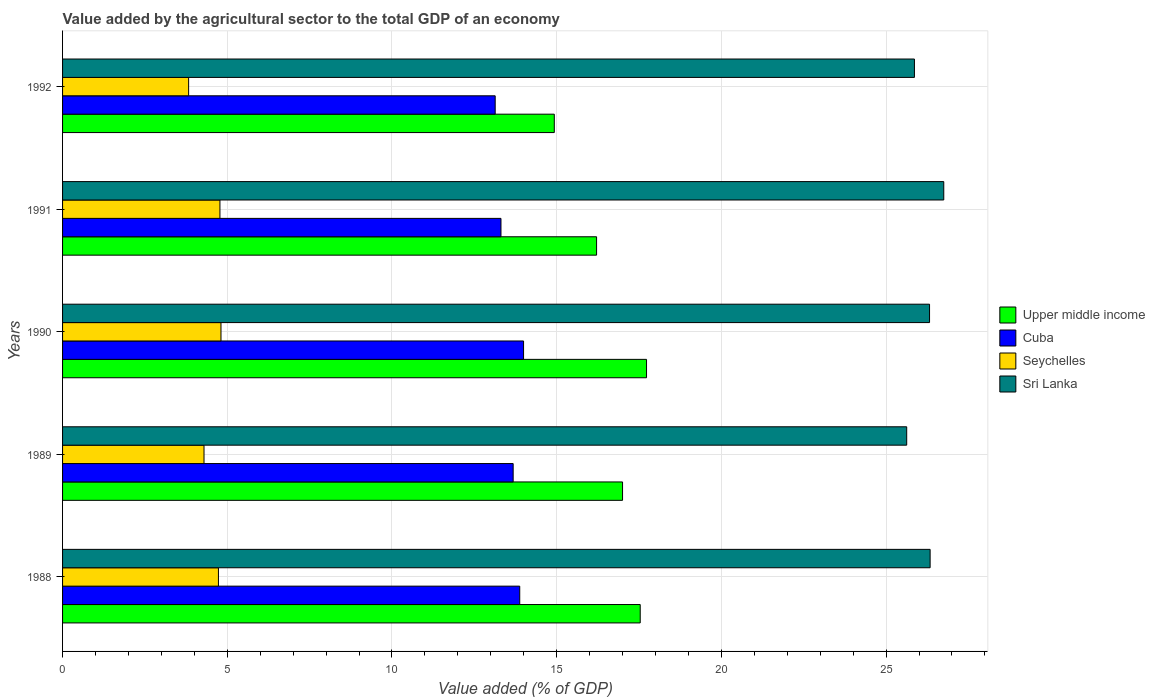How many different coloured bars are there?
Your answer should be compact. 4. Are the number of bars per tick equal to the number of legend labels?
Ensure brevity in your answer.  Yes. Are the number of bars on each tick of the Y-axis equal?
Provide a succinct answer. Yes. How many bars are there on the 3rd tick from the top?
Ensure brevity in your answer.  4. In how many cases, is the number of bars for a given year not equal to the number of legend labels?
Your response must be concise. 0. What is the value added by the agricultural sector to the total GDP in Cuba in 1992?
Provide a short and direct response. 13.13. Across all years, what is the maximum value added by the agricultural sector to the total GDP in Sri Lanka?
Offer a very short reply. 26.75. Across all years, what is the minimum value added by the agricultural sector to the total GDP in Upper middle income?
Make the answer very short. 14.93. What is the total value added by the agricultural sector to the total GDP in Seychelles in the graph?
Provide a short and direct response. 22.44. What is the difference between the value added by the agricultural sector to the total GDP in Cuba in 1991 and that in 1992?
Offer a very short reply. 0.18. What is the difference between the value added by the agricultural sector to the total GDP in Upper middle income in 1990 and the value added by the agricultural sector to the total GDP in Seychelles in 1991?
Offer a very short reply. 12.95. What is the average value added by the agricultural sector to the total GDP in Upper middle income per year?
Offer a very short reply. 16.68. In the year 1991, what is the difference between the value added by the agricultural sector to the total GDP in Cuba and value added by the agricultural sector to the total GDP in Sri Lanka?
Your answer should be very brief. -13.44. What is the ratio of the value added by the agricultural sector to the total GDP in Cuba in 1988 to that in 1992?
Offer a terse response. 1.06. Is the value added by the agricultural sector to the total GDP in Upper middle income in 1991 less than that in 1992?
Offer a terse response. No. What is the difference between the highest and the second highest value added by the agricultural sector to the total GDP in Cuba?
Your answer should be very brief. 0.12. What is the difference between the highest and the lowest value added by the agricultural sector to the total GDP in Upper middle income?
Make the answer very short. 2.8. In how many years, is the value added by the agricultural sector to the total GDP in Upper middle income greater than the average value added by the agricultural sector to the total GDP in Upper middle income taken over all years?
Offer a very short reply. 3. Is the sum of the value added by the agricultural sector to the total GDP in Upper middle income in 1988 and 1991 greater than the maximum value added by the agricultural sector to the total GDP in Seychelles across all years?
Provide a succinct answer. Yes. Is it the case that in every year, the sum of the value added by the agricultural sector to the total GDP in Cuba and value added by the agricultural sector to the total GDP in Seychelles is greater than the sum of value added by the agricultural sector to the total GDP in Upper middle income and value added by the agricultural sector to the total GDP in Sri Lanka?
Your answer should be very brief. No. What does the 1st bar from the top in 1991 represents?
Ensure brevity in your answer.  Sri Lanka. What does the 3rd bar from the bottom in 1988 represents?
Offer a terse response. Seychelles. Is it the case that in every year, the sum of the value added by the agricultural sector to the total GDP in Cuba and value added by the agricultural sector to the total GDP in Sri Lanka is greater than the value added by the agricultural sector to the total GDP in Upper middle income?
Ensure brevity in your answer.  Yes. How many bars are there?
Your answer should be very brief. 20. Are all the bars in the graph horizontal?
Provide a short and direct response. Yes. What is the difference between two consecutive major ticks on the X-axis?
Give a very brief answer. 5. Where does the legend appear in the graph?
Give a very brief answer. Center right. How many legend labels are there?
Provide a short and direct response. 4. What is the title of the graph?
Give a very brief answer. Value added by the agricultural sector to the total GDP of an economy. Does "European Union" appear as one of the legend labels in the graph?
Offer a terse response. No. What is the label or title of the X-axis?
Your response must be concise. Value added (% of GDP). What is the Value added (% of GDP) in Upper middle income in 1988?
Ensure brevity in your answer.  17.54. What is the Value added (% of GDP) of Cuba in 1988?
Offer a terse response. 13.88. What is the Value added (% of GDP) in Seychelles in 1988?
Ensure brevity in your answer.  4.73. What is the Value added (% of GDP) in Sri Lanka in 1988?
Provide a succinct answer. 26.34. What is the Value added (% of GDP) in Upper middle income in 1989?
Ensure brevity in your answer.  17. What is the Value added (% of GDP) in Cuba in 1989?
Provide a succinct answer. 13.68. What is the Value added (% of GDP) of Seychelles in 1989?
Your answer should be compact. 4.29. What is the Value added (% of GDP) in Sri Lanka in 1989?
Offer a very short reply. 25.63. What is the Value added (% of GDP) in Upper middle income in 1990?
Provide a short and direct response. 17.73. What is the Value added (% of GDP) in Cuba in 1990?
Provide a succinct answer. 13.99. What is the Value added (% of GDP) of Seychelles in 1990?
Make the answer very short. 4.81. What is the Value added (% of GDP) in Sri Lanka in 1990?
Your response must be concise. 26.32. What is the Value added (% of GDP) of Upper middle income in 1991?
Your response must be concise. 16.21. What is the Value added (% of GDP) of Cuba in 1991?
Provide a short and direct response. 13.31. What is the Value added (% of GDP) of Seychelles in 1991?
Offer a very short reply. 4.78. What is the Value added (% of GDP) in Sri Lanka in 1991?
Provide a succinct answer. 26.75. What is the Value added (% of GDP) in Upper middle income in 1992?
Offer a very short reply. 14.93. What is the Value added (% of GDP) of Cuba in 1992?
Offer a terse response. 13.13. What is the Value added (% of GDP) of Seychelles in 1992?
Keep it short and to the point. 3.83. What is the Value added (% of GDP) of Sri Lanka in 1992?
Give a very brief answer. 25.86. Across all years, what is the maximum Value added (% of GDP) in Upper middle income?
Make the answer very short. 17.73. Across all years, what is the maximum Value added (% of GDP) of Cuba?
Your answer should be very brief. 13.99. Across all years, what is the maximum Value added (% of GDP) of Seychelles?
Keep it short and to the point. 4.81. Across all years, what is the maximum Value added (% of GDP) of Sri Lanka?
Ensure brevity in your answer.  26.75. Across all years, what is the minimum Value added (% of GDP) of Upper middle income?
Your answer should be very brief. 14.93. Across all years, what is the minimum Value added (% of GDP) of Cuba?
Offer a terse response. 13.13. Across all years, what is the minimum Value added (% of GDP) of Seychelles?
Provide a short and direct response. 3.83. Across all years, what is the minimum Value added (% of GDP) of Sri Lanka?
Give a very brief answer. 25.63. What is the total Value added (% of GDP) of Upper middle income in the graph?
Your answer should be compact. 83.4. What is the total Value added (% of GDP) of Cuba in the graph?
Provide a short and direct response. 67.99. What is the total Value added (% of GDP) in Seychelles in the graph?
Keep it short and to the point. 22.44. What is the total Value added (% of GDP) in Sri Lanka in the graph?
Your answer should be compact. 130.89. What is the difference between the Value added (% of GDP) of Upper middle income in 1988 and that in 1989?
Keep it short and to the point. 0.54. What is the difference between the Value added (% of GDP) in Cuba in 1988 and that in 1989?
Your response must be concise. 0.2. What is the difference between the Value added (% of GDP) of Seychelles in 1988 and that in 1989?
Your answer should be compact. 0.44. What is the difference between the Value added (% of GDP) in Sri Lanka in 1988 and that in 1989?
Keep it short and to the point. 0.71. What is the difference between the Value added (% of GDP) of Upper middle income in 1988 and that in 1990?
Ensure brevity in your answer.  -0.19. What is the difference between the Value added (% of GDP) of Cuba in 1988 and that in 1990?
Ensure brevity in your answer.  -0.12. What is the difference between the Value added (% of GDP) of Seychelles in 1988 and that in 1990?
Your answer should be compact. -0.08. What is the difference between the Value added (% of GDP) of Sri Lanka in 1988 and that in 1990?
Provide a succinct answer. 0.02. What is the difference between the Value added (% of GDP) in Upper middle income in 1988 and that in 1991?
Keep it short and to the point. 1.32. What is the difference between the Value added (% of GDP) in Cuba in 1988 and that in 1991?
Offer a terse response. 0.57. What is the difference between the Value added (% of GDP) in Seychelles in 1988 and that in 1991?
Make the answer very short. -0.05. What is the difference between the Value added (% of GDP) of Sri Lanka in 1988 and that in 1991?
Ensure brevity in your answer.  -0.41. What is the difference between the Value added (% of GDP) of Upper middle income in 1988 and that in 1992?
Offer a very short reply. 2.61. What is the difference between the Value added (% of GDP) of Cuba in 1988 and that in 1992?
Ensure brevity in your answer.  0.75. What is the difference between the Value added (% of GDP) of Seychelles in 1988 and that in 1992?
Make the answer very short. 0.9. What is the difference between the Value added (% of GDP) of Sri Lanka in 1988 and that in 1992?
Give a very brief answer. 0.48. What is the difference between the Value added (% of GDP) of Upper middle income in 1989 and that in 1990?
Your answer should be very brief. -0.73. What is the difference between the Value added (% of GDP) of Cuba in 1989 and that in 1990?
Your response must be concise. -0.32. What is the difference between the Value added (% of GDP) in Seychelles in 1989 and that in 1990?
Ensure brevity in your answer.  -0.52. What is the difference between the Value added (% of GDP) of Sri Lanka in 1989 and that in 1990?
Offer a terse response. -0.69. What is the difference between the Value added (% of GDP) in Upper middle income in 1989 and that in 1991?
Offer a very short reply. 0.79. What is the difference between the Value added (% of GDP) of Cuba in 1989 and that in 1991?
Offer a very short reply. 0.37. What is the difference between the Value added (% of GDP) of Seychelles in 1989 and that in 1991?
Your answer should be compact. -0.48. What is the difference between the Value added (% of GDP) in Sri Lanka in 1989 and that in 1991?
Keep it short and to the point. -1.13. What is the difference between the Value added (% of GDP) in Upper middle income in 1989 and that in 1992?
Keep it short and to the point. 2.07. What is the difference between the Value added (% of GDP) of Cuba in 1989 and that in 1992?
Make the answer very short. 0.55. What is the difference between the Value added (% of GDP) in Seychelles in 1989 and that in 1992?
Give a very brief answer. 0.47. What is the difference between the Value added (% of GDP) in Sri Lanka in 1989 and that in 1992?
Keep it short and to the point. -0.23. What is the difference between the Value added (% of GDP) of Upper middle income in 1990 and that in 1991?
Provide a succinct answer. 1.52. What is the difference between the Value added (% of GDP) of Cuba in 1990 and that in 1991?
Make the answer very short. 0.69. What is the difference between the Value added (% of GDP) of Seychelles in 1990 and that in 1991?
Make the answer very short. 0.03. What is the difference between the Value added (% of GDP) in Sri Lanka in 1990 and that in 1991?
Offer a terse response. -0.43. What is the difference between the Value added (% of GDP) in Upper middle income in 1990 and that in 1992?
Provide a short and direct response. 2.8. What is the difference between the Value added (% of GDP) of Cuba in 1990 and that in 1992?
Provide a short and direct response. 0.86. What is the difference between the Value added (% of GDP) in Seychelles in 1990 and that in 1992?
Make the answer very short. 0.98. What is the difference between the Value added (% of GDP) of Sri Lanka in 1990 and that in 1992?
Ensure brevity in your answer.  0.46. What is the difference between the Value added (% of GDP) of Upper middle income in 1991 and that in 1992?
Make the answer very short. 1.28. What is the difference between the Value added (% of GDP) in Cuba in 1991 and that in 1992?
Keep it short and to the point. 0.18. What is the difference between the Value added (% of GDP) of Seychelles in 1991 and that in 1992?
Provide a short and direct response. 0.95. What is the difference between the Value added (% of GDP) of Sri Lanka in 1991 and that in 1992?
Offer a very short reply. 0.89. What is the difference between the Value added (% of GDP) of Upper middle income in 1988 and the Value added (% of GDP) of Cuba in 1989?
Provide a short and direct response. 3.86. What is the difference between the Value added (% of GDP) of Upper middle income in 1988 and the Value added (% of GDP) of Seychelles in 1989?
Ensure brevity in your answer.  13.24. What is the difference between the Value added (% of GDP) of Upper middle income in 1988 and the Value added (% of GDP) of Sri Lanka in 1989?
Your response must be concise. -8.09. What is the difference between the Value added (% of GDP) of Cuba in 1988 and the Value added (% of GDP) of Seychelles in 1989?
Keep it short and to the point. 9.58. What is the difference between the Value added (% of GDP) in Cuba in 1988 and the Value added (% of GDP) in Sri Lanka in 1989?
Provide a succinct answer. -11.75. What is the difference between the Value added (% of GDP) of Seychelles in 1988 and the Value added (% of GDP) of Sri Lanka in 1989?
Offer a very short reply. -20.89. What is the difference between the Value added (% of GDP) of Upper middle income in 1988 and the Value added (% of GDP) of Cuba in 1990?
Ensure brevity in your answer.  3.54. What is the difference between the Value added (% of GDP) in Upper middle income in 1988 and the Value added (% of GDP) in Seychelles in 1990?
Offer a very short reply. 12.73. What is the difference between the Value added (% of GDP) in Upper middle income in 1988 and the Value added (% of GDP) in Sri Lanka in 1990?
Offer a terse response. -8.78. What is the difference between the Value added (% of GDP) of Cuba in 1988 and the Value added (% of GDP) of Seychelles in 1990?
Your response must be concise. 9.07. What is the difference between the Value added (% of GDP) in Cuba in 1988 and the Value added (% of GDP) in Sri Lanka in 1990?
Give a very brief answer. -12.44. What is the difference between the Value added (% of GDP) in Seychelles in 1988 and the Value added (% of GDP) in Sri Lanka in 1990?
Provide a short and direct response. -21.59. What is the difference between the Value added (% of GDP) in Upper middle income in 1988 and the Value added (% of GDP) in Cuba in 1991?
Keep it short and to the point. 4.23. What is the difference between the Value added (% of GDP) of Upper middle income in 1988 and the Value added (% of GDP) of Seychelles in 1991?
Your response must be concise. 12.76. What is the difference between the Value added (% of GDP) of Upper middle income in 1988 and the Value added (% of GDP) of Sri Lanka in 1991?
Your answer should be compact. -9.21. What is the difference between the Value added (% of GDP) in Cuba in 1988 and the Value added (% of GDP) in Seychelles in 1991?
Offer a terse response. 9.1. What is the difference between the Value added (% of GDP) of Cuba in 1988 and the Value added (% of GDP) of Sri Lanka in 1991?
Give a very brief answer. -12.87. What is the difference between the Value added (% of GDP) in Seychelles in 1988 and the Value added (% of GDP) in Sri Lanka in 1991?
Your answer should be compact. -22.02. What is the difference between the Value added (% of GDP) in Upper middle income in 1988 and the Value added (% of GDP) in Cuba in 1992?
Give a very brief answer. 4.4. What is the difference between the Value added (% of GDP) in Upper middle income in 1988 and the Value added (% of GDP) in Seychelles in 1992?
Offer a very short reply. 13.71. What is the difference between the Value added (% of GDP) of Upper middle income in 1988 and the Value added (% of GDP) of Sri Lanka in 1992?
Provide a short and direct response. -8.32. What is the difference between the Value added (% of GDP) in Cuba in 1988 and the Value added (% of GDP) in Seychelles in 1992?
Your answer should be compact. 10.05. What is the difference between the Value added (% of GDP) in Cuba in 1988 and the Value added (% of GDP) in Sri Lanka in 1992?
Your response must be concise. -11.98. What is the difference between the Value added (% of GDP) in Seychelles in 1988 and the Value added (% of GDP) in Sri Lanka in 1992?
Provide a short and direct response. -21.13. What is the difference between the Value added (% of GDP) in Upper middle income in 1989 and the Value added (% of GDP) in Cuba in 1990?
Keep it short and to the point. 3. What is the difference between the Value added (% of GDP) in Upper middle income in 1989 and the Value added (% of GDP) in Seychelles in 1990?
Provide a succinct answer. 12.19. What is the difference between the Value added (% of GDP) of Upper middle income in 1989 and the Value added (% of GDP) of Sri Lanka in 1990?
Your answer should be compact. -9.32. What is the difference between the Value added (% of GDP) in Cuba in 1989 and the Value added (% of GDP) in Seychelles in 1990?
Ensure brevity in your answer.  8.87. What is the difference between the Value added (% of GDP) of Cuba in 1989 and the Value added (% of GDP) of Sri Lanka in 1990?
Your answer should be very brief. -12.64. What is the difference between the Value added (% of GDP) in Seychelles in 1989 and the Value added (% of GDP) in Sri Lanka in 1990?
Give a very brief answer. -22.03. What is the difference between the Value added (% of GDP) of Upper middle income in 1989 and the Value added (% of GDP) of Cuba in 1991?
Your response must be concise. 3.69. What is the difference between the Value added (% of GDP) in Upper middle income in 1989 and the Value added (% of GDP) in Seychelles in 1991?
Offer a terse response. 12.22. What is the difference between the Value added (% of GDP) of Upper middle income in 1989 and the Value added (% of GDP) of Sri Lanka in 1991?
Offer a terse response. -9.75. What is the difference between the Value added (% of GDP) of Cuba in 1989 and the Value added (% of GDP) of Seychelles in 1991?
Give a very brief answer. 8.9. What is the difference between the Value added (% of GDP) of Cuba in 1989 and the Value added (% of GDP) of Sri Lanka in 1991?
Keep it short and to the point. -13.07. What is the difference between the Value added (% of GDP) in Seychelles in 1989 and the Value added (% of GDP) in Sri Lanka in 1991?
Give a very brief answer. -22.46. What is the difference between the Value added (% of GDP) of Upper middle income in 1989 and the Value added (% of GDP) of Cuba in 1992?
Your answer should be very brief. 3.87. What is the difference between the Value added (% of GDP) of Upper middle income in 1989 and the Value added (% of GDP) of Seychelles in 1992?
Your answer should be very brief. 13.17. What is the difference between the Value added (% of GDP) in Upper middle income in 1989 and the Value added (% of GDP) in Sri Lanka in 1992?
Make the answer very short. -8.86. What is the difference between the Value added (% of GDP) in Cuba in 1989 and the Value added (% of GDP) in Seychelles in 1992?
Give a very brief answer. 9.85. What is the difference between the Value added (% of GDP) of Cuba in 1989 and the Value added (% of GDP) of Sri Lanka in 1992?
Give a very brief answer. -12.18. What is the difference between the Value added (% of GDP) of Seychelles in 1989 and the Value added (% of GDP) of Sri Lanka in 1992?
Provide a succinct answer. -21.57. What is the difference between the Value added (% of GDP) in Upper middle income in 1990 and the Value added (% of GDP) in Cuba in 1991?
Keep it short and to the point. 4.42. What is the difference between the Value added (% of GDP) of Upper middle income in 1990 and the Value added (% of GDP) of Seychelles in 1991?
Give a very brief answer. 12.95. What is the difference between the Value added (% of GDP) in Upper middle income in 1990 and the Value added (% of GDP) in Sri Lanka in 1991?
Your answer should be very brief. -9.02. What is the difference between the Value added (% of GDP) of Cuba in 1990 and the Value added (% of GDP) of Seychelles in 1991?
Provide a succinct answer. 9.22. What is the difference between the Value added (% of GDP) of Cuba in 1990 and the Value added (% of GDP) of Sri Lanka in 1991?
Your answer should be very brief. -12.76. What is the difference between the Value added (% of GDP) of Seychelles in 1990 and the Value added (% of GDP) of Sri Lanka in 1991?
Ensure brevity in your answer.  -21.94. What is the difference between the Value added (% of GDP) of Upper middle income in 1990 and the Value added (% of GDP) of Cuba in 1992?
Give a very brief answer. 4.59. What is the difference between the Value added (% of GDP) of Upper middle income in 1990 and the Value added (% of GDP) of Seychelles in 1992?
Your answer should be very brief. 13.9. What is the difference between the Value added (% of GDP) of Upper middle income in 1990 and the Value added (% of GDP) of Sri Lanka in 1992?
Ensure brevity in your answer.  -8.13. What is the difference between the Value added (% of GDP) in Cuba in 1990 and the Value added (% of GDP) in Seychelles in 1992?
Give a very brief answer. 10.17. What is the difference between the Value added (% of GDP) of Cuba in 1990 and the Value added (% of GDP) of Sri Lanka in 1992?
Offer a terse response. -11.87. What is the difference between the Value added (% of GDP) of Seychelles in 1990 and the Value added (% of GDP) of Sri Lanka in 1992?
Offer a terse response. -21.05. What is the difference between the Value added (% of GDP) in Upper middle income in 1991 and the Value added (% of GDP) in Cuba in 1992?
Offer a terse response. 3.08. What is the difference between the Value added (% of GDP) in Upper middle income in 1991 and the Value added (% of GDP) in Seychelles in 1992?
Keep it short and to the point. 12.38. What is the difference between the Value added (% of GDP) in Upper middle income in 1991 and the Value added (% of GDP) in Sri Lanka in 1992?
Provide a succinct answer. -9.65. What is the difference between the Value added (% of GDP) in Cuba in 1991 and the Value added (% of GDP) in Seychelles in 1992?
Ensure brevity in your answer.  9.48. What is the difference between the Value added (% of GDP) in Cuba in 1991 and the Value added (% of GDP) in Sri Lanka in 1992?
Provide a succinct answer. -12.55. What is the difference between the Value added (% of GDP) in Seychelles in 1991 and the Value added (% of GDP) in Sri Lanka in 1992?
Provide a short and direct response. -21.08. What is the average Value added (% of GDP) in Upper middle income per year?
Offer a terse response. 16.68. What is the average Value added (% of GDP) in Cuba per year?
Your answer should be compact. 13.6. What is the average Value added (% of GDP) in Seychelles per year?
Provide a short and direct response. 4.49. What is the average Value added (% of GDP) of Sri Lanka per year?
Provide a short and direct response. 26.18. In the year 1988, what is the difference between the Value added (% of GDP) in Upper middle income and Value added (% of GDP) in Cuba?
Your answer should be very brief. 3.66. In the year 1988, what is the difference between the Value added (% of GDP) of Upper middle income and Value added (% of GDP) of Seychelles?
Your answer should be very brief. 12.8. In the year 1988, what is the difference between the Value added (% of GDP) in Upper middle income and Value added (% of GDP) in Sri Lanka?
Your response must be concise. -8.8. In the year 1988, what is the difference between the Value added (% of GDP) of Cuba and Value added (% of GDP) of Seychelles?
Keep it short and to the point. 9.15. In the year 1988, what is the difference between the Value added (% of GDP) of Cuba and Value added (% of GDP) of Sri Lanka?
Give a very brief answer. -12.46. In the year 1988, what is the difference between the Value added (% of GDP) in Seychelles and Value added (% of GDP) in Sri Lanka?
Offer a very short reply. -21.61. In the year 1989, what is the difference between the Value added (% of GDP) in Upper middle income and Value added (% of GDP) in Cuba?
Your answer should be very brief. 3.32. In the year 1989, what is the difference between the Value added (% of GDP) in Upper middle income and Value added (% of GDP) in Seychelles?
Provide a short and direct response. 12.71. In the year 1989, what is the difference between the Value added (% of GDP) of Upper middle income and Value added (% of GDP) of Sri Lanka?
Provide a succinct answer. -8.63. In the year 1989, what is the difference between the Value added (% of GDP) in Cuba and Value added (% of GDP) in Seychelles?
Ensure brevity in your answer.  9.38. In the year 1989, what is the difference between the Value added (% of GDP) in Cuba and Value added (% of GDP) in Sri Lanka?
Ensure brevity in your answer.  -11.95. In the year 1989, what is the difference between the Value added (% of GDP) of Seychelles and Value added (% of GDP) of Sri Lanka?
Your answer should be compact. -21.33. In the year 1990, what is the difference between the Value added (% of GDP) in Upper middle income and Value added (% of GDP) in Cuba?
Provide a short and direct response. 3.73. In the year 1990, what is the difference between the Value added (% of GDP) in Upper middle income and Value added (% of GDP) in Seychelles?
Offer a very short reply. 12.92. In the year 1990, what is the difference between the Value added (% of GDP) of Upper middle income and Value added (% of GDP) of Sri Lanka?
Give a very brief answer. -8.59. In the year 1990, what is the difference between the Value added (% of GDP) of Cuba and Value added (% of GDP) of Seychelles?
Ensure brevity in your answer.  9.19. In the year 1990, what is the difference between the Value added (% of GDP) in Cuba and Value added (% of GDP) in Sri Lanka?
Provide a short and direct response. -12.32. In the year 1990, what is the difference between the Value added (% of GDP) in Seychelles and Value added (% of GDP) in Sri Lanka?
Offer a very short reply. -21.51. In the year 1991, what is the difference between the Value added (% of GDP) of Upper middle income and Value added (% of GDP) of Cuba?
Your response must be concise. 2.9. In the year 1991, what is the difference between the Value added (% of GDP) of Upper middle income and Value added (% of GDP) of Seychelles?
Provide a succinct answer. 11.43. In the year 1991, what is the difference between the Value added (% of GDP) in Upper middle income and Value added (% of GDP) in Sri Lanka?
Provide a succinct answer. -10.54. In the year 1991, what is the difference between the Value added (% of GDP) of Cuba and Value added (% of GDP) of Seychelles?
Keep it short and to the point. 8.53. In the year 1991, what is the difference between the Value added (% of GDP) in Cuba and Value added (% of GDP) in Sri Lanka?
Make the answer very short. -13.44. In the year 1991, what is the difference between the Value added (% of GDP) of Seychelles and Value added (% of GDP) of Sri Lanka?
Make the answer very short. -21.97. In the year 1992, what is the difference between the Value added (% of GDP) of Upper middle income and Value added (% of GDP) of Cuba?
Offer a terse response. 1.79. In the year 1992, what is the difference between the Value added (% of GDP) in Upper middle income and Value added (% of GDP) in Seychelles?
Offer a terse response. 11.1. In the year 1992, what is the difference between the Value added (% of GDP) of Upper middle income and Value added (% of GDP) of Sri Lanka?
Ensure brevity in your answer.  -10.93. In the year 1992, what is the difference between the Value added (% of GDP) of Cuba and Value added (% of GDP) of Seychelles?
Ensure brevity in your answer.  9.31. In the year 1992, what is the difference between the Value added (% of GDP) in Cuba and Value added (% of GDP) in Sri Lanka?
Your answer should be compact. -12.73. In the year 1992, what is the difference between the Value added (% of GDP) of Seychelles and Value added (% of GDP) of Sri Lanka?
Provide a succinct answer. -22.03. What is the ratio of the Value added (% of GDP) in Upper middle income in 1988 to that in 1989?
Ensure brevity in your answer.  1.03. What is the ratio of the Value added (% of GDP) of Cuba in 1988 to that in 1989?
Your answer should be very brief. 1.01. What is the ratio of the Value added (% of GDP) of Seychelles in 1988 to that in 1989?
Provide a short and direct response. 1.1. What is the ratio of the Value added (% of GDP) of Sri Lanka in 1988 to that in 1989?
Keep it short and to the point. 1.03. What is the ratio of the Value added (% of GDP) in Upper middle income in 1988 to that in 1990?
Offer a terse response. 0.99. What is the ratio of the Value added (% of GDP) of Seychelles in 1988 to that in 1990?
Your response must be concise. 0.98. What is the ratio of the Value added (% of GDP) of Upper middle income in 1988 to that in 1991?
Keep it short and to the point. 1.08. What is the ratio of the Value added (% of GDP) in Cuba in 1988 to that in 1991?
Offer a terse response. 1.04. What is the ratio of the Value added (% of GDP) of Seychelles in 1988 to that in 1991?
Give a very brief answer. 0.99. What is the ratio of the Value added (% of GDP) in Sri Lanka in 1988 to that in 1991?
Your answer should be compact. 0.98. What is the ratio of the Value added (% of GDP) of Upper middle income in 1988 to that in 1992?
Provide a short and direct response. 1.17. What is the ratio of the Value added (% of GDP) in Cuba in 1988 to that in 1992?
Your answer should be compact. 1.06. What is the ratio of the Value added (% of GDP) in Seychelles in 1988 to that in 1992?
Provide a succinct answer. 1.24. What is the ratio of the Value added (% of GDP) of Sri Lanka in 1988 to that in 1992?
Your response must be concise. 1.02. What is the ratio of the Value added (% of GDP) in Upper middle income in 1989 to that in 1990?
Give a very brief answer. 0.96. What is the ratio of the Value added (% of GDP) of Cuba in 1989 to that in 1990?
Your answer should be compact. 0.98. What is the ratio of the Value added (% of GDP) of Seychelles in 1989 to that in 1990?
Provide a short and direct response. 0.89. What is the ratio of the Value added (% of GDP) in Sri Lanka in 1989 to that in 1990?
Make the answer very short. 0.97. What is the ratio of the Value added (% of GDP) in Upper middle income in 1989 to that in 1991?
Ensure brevity in your answer.  1.05. What is the ratio of the Value added (% of GDP) of Cuba in 1989 to that in 1991?
Your response must be concise. 1.03. What is the ratio of the Value added (% of GDP) of Seychelles in 1989 to that in 1991?
Your answer should be very brief. 0.9. What is the ratio of the Value added (% of GDP) in Sri Lanka in 1989 to that in 1991?
Your answer should be compact. 0.96. What is the ratio of the Value added (% of GDP) in Upper middle income in 1989 to that in 1992?
Give a very brief answer. 1.14. What is the ratio of the Value added (% of GDP) of Cuba in 1989 to that in 1992?
Offer a terse response. 1.04. What is the ratio of the Value added (% of GDP) of Seychelles in 1989 to that in 1992?
Ensure brevity in your answer.  1.12. What is the ratio of the Value added (% of GDP) in Sri Lanka in 1989 to that in 1992?
Your answer should be compact. 0.99. What is the ratio of the Value added (% of GDP) in Upper middle income in 1990 to that in 1991?
Keep it short and to the point. 1.09. What is the ratio of the Value added (% of GDP) of Cuba in 1990 to that in 1991?
Provide a short and direct response. 1.05. What is the ratio of the Value added (% of GDP) in Seychelles in 1990 to that in 1991?
Your response must be concise. 1.01. What is the ratio of the Value added (% of GDP) in Sri Lanka in 1990 to that in 1991?
Your answer should be compact. 0.98. What is the ratio of the Value added (% of GDP) in Upper middle income in 1990 to that in 1992?
Make the answer very short. 1.19. What is the ratio of the Value added (% of GDP) of Cuba in 1990 to that in 1992?
Offer a very short reply. 1.07. What is the ratio of the Value added (% of GDP) in Seychelles in 1990 to that in 1992?
Provide a short and direct response. 1.26. What is the ratio of the Value added (% of GDP) in Sri Lanka in 1990 to that in 1992?
Your answer should be compact. 1.02. What is the ratio of the Value added (% of GDP) in Upper middle income in 1991 to that in 1992?
Your response must be concise. 1.09. What is the ratio of the Value added (% of GDP) in Cuba in 1991 to that in 1992?
Give a very brief answer. 1.01. What is the ratio of the Value added (% of GDP) in Seychelles in 1991 to that in 1992?
Give a very brief answer. 1.25. What is the ratio of the Value added (% of GDP) in Sri Lanka in 1991 to that in 1992?
Your answer should be compact. 1.03. What is the difference between the highest and the second highest Value added (% of GDP) of Upper middle income?
Provide a short and direct response. 0.19. What is the difference between the highest and the second highest Value added (% of GDP) of Cuba?
Your response must be concise. 0.12. What is the difference between the highest and the second highest Value added (% of GDP) in Seychelles?
Keep it short and to the point. 0.03. What is the difference between the highest and the second highest Value added (% of GDP) of Sri Lanka?
Ensure brevity in your answer.  0.41. What is the difference between the highest and the lowest Value added (% of GDP) in Upper middle income?
Your response must be concise. 2.8. What is the difference between the highest and the lowest Value added (% of GDP) in Cuba?
Your answer should be very brief. 0.86. What is the difference between the highest and the lowest Value added (% of GDP) in Seychelles?
Provide a short and direct response. 0.98. What is the difference between the highest and the lowest Value added (% of GDP) in Sri Lanka?
Ensure brevity in your answer.  1.13. 